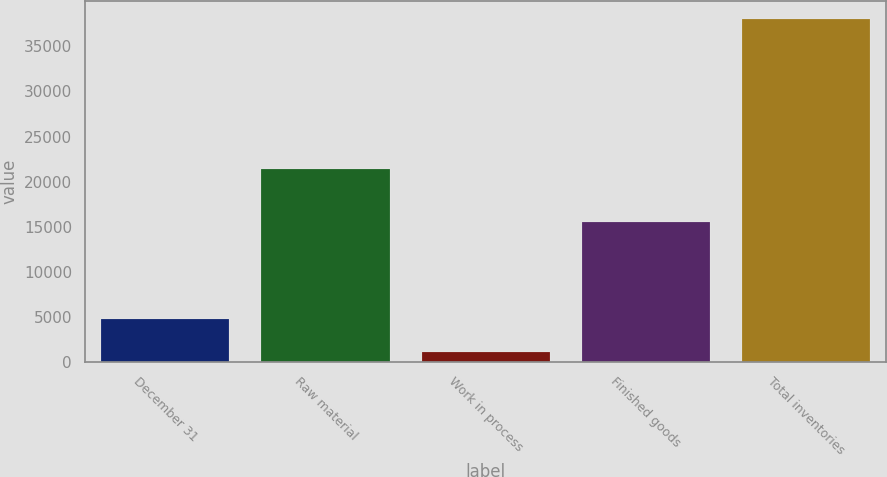Convert chart. <chart><loc_0><loc_0><loc_500><loc_500><bar_chart><fcel>December 31<fcel>Raw material<fcel>Work in process<fcel>Finished goods<fcel>Total inventories<nl><fcel>4800.2<fcel>21404<fcel>1104<fcel>15558<fcel>38066<nl></chart> 